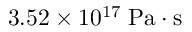Convert formula to latex. <formula><loc_0><loc_0><loc_500><loc_500>3 . 5 2 \times 1 0 ^ { 1 7 } \, P a \cdot s</formula> 